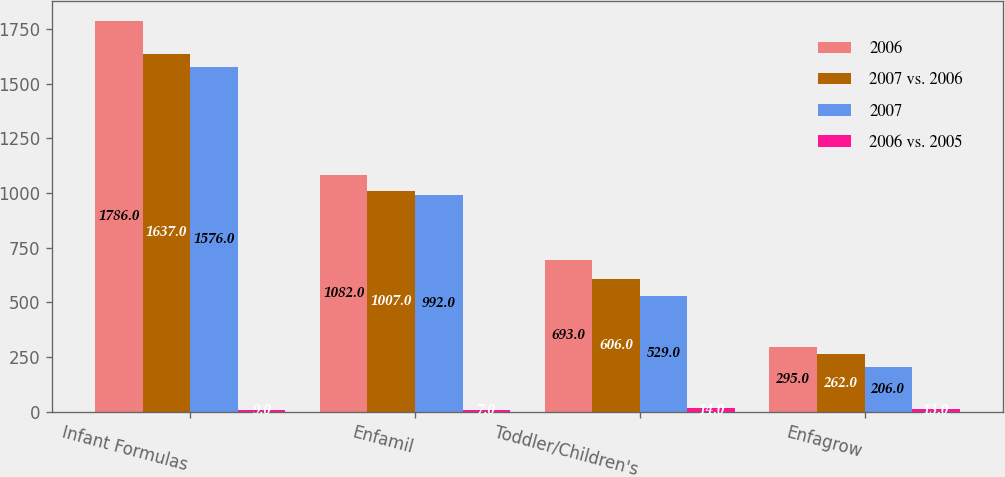Convert chart. <chart><loc_0><loc_0><loc_500><loc_500><stacked_bar_chart><ecel><fcel>Infant Formulas<fcel>Enfamil<fcel>Toddler/Children's<fcel>Enfagrow<nl><fcel>2006<fcel>1786<fcel>1082<fcel>693<fcel>295<nl><fcel>2007 vs. 2006<fcel>1637<fcel>1007<fcel>606<fcel>262<nl><fcel>2007<fcel>1576<fcel>992<fcel>529<fcel>206<nl><fcel>2006 vs. 2005<fcel>9<fcel>7<fcel>14<fcel>13<nl></chart> 